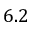Convert formula to latex. <formula><loc_0><loc_0><loc_500><loc_500>6 . 2</formula> 